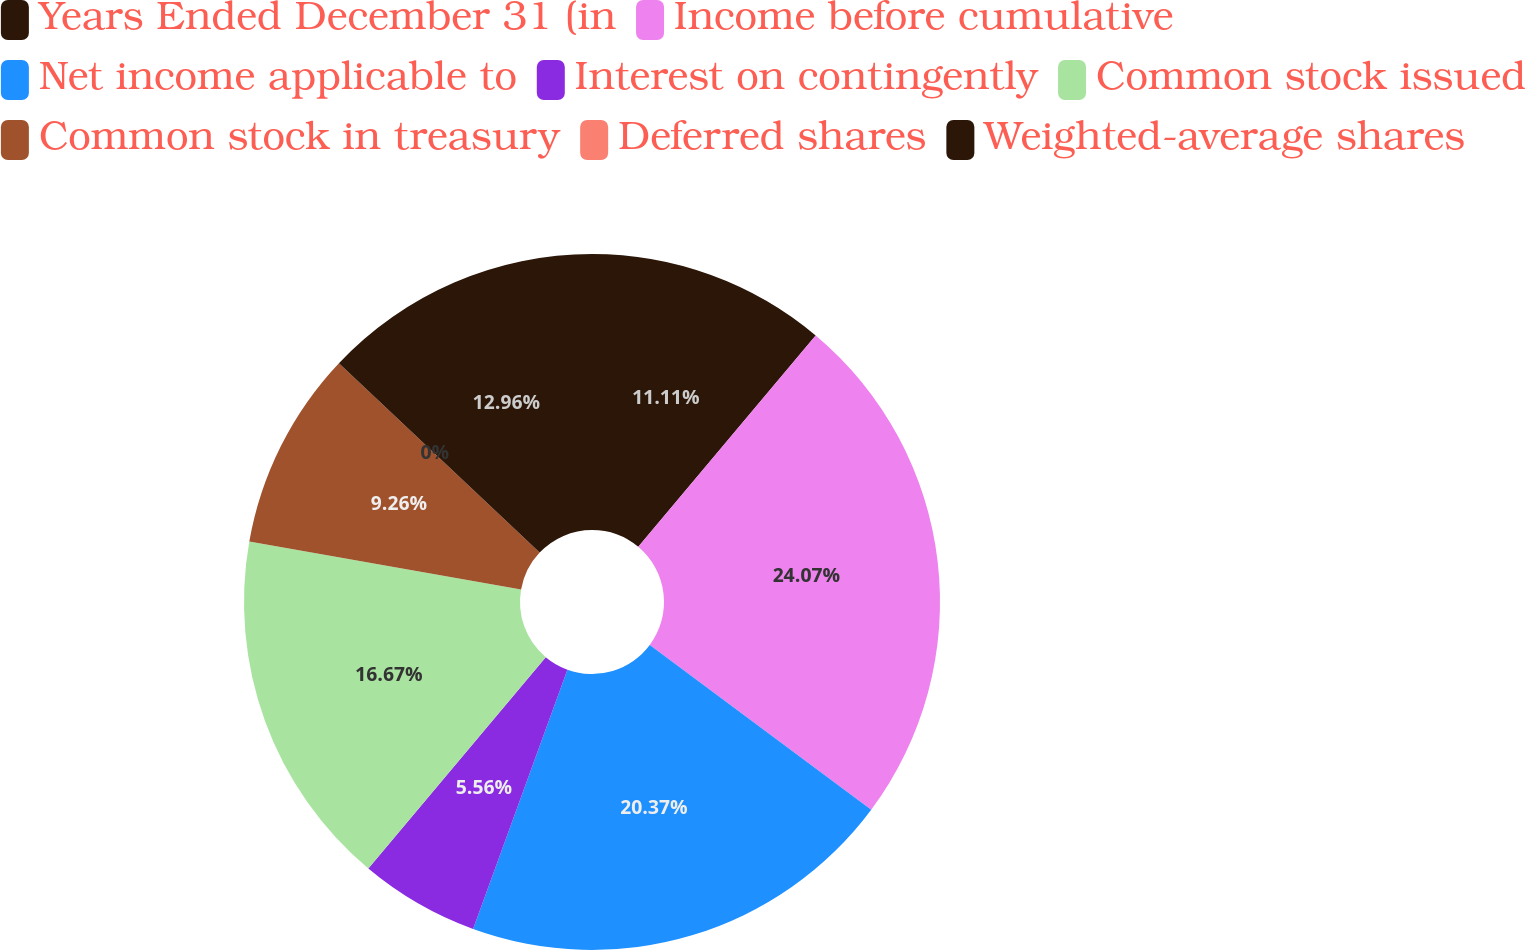<chart> <loc_0><loc_0><loc_500><loc_500><pie_chart><fcel>Years Ended December 31 (in<fcel>Income before cumulative<fcel>Net income applicable to<fcel>Interest on contingently<fcel>Common stock issued<fcel>Common stock in treasury<fcel>Deferred shares<fcel>Weighted-average shares<nl><fcel>11.11%<fcel>24.07%<fcel>20.37%<fcel>5.56%<fcel>16.67%<fcel>9.26%<fcel>0.0%<fcel>12.96%<nl></chart> 